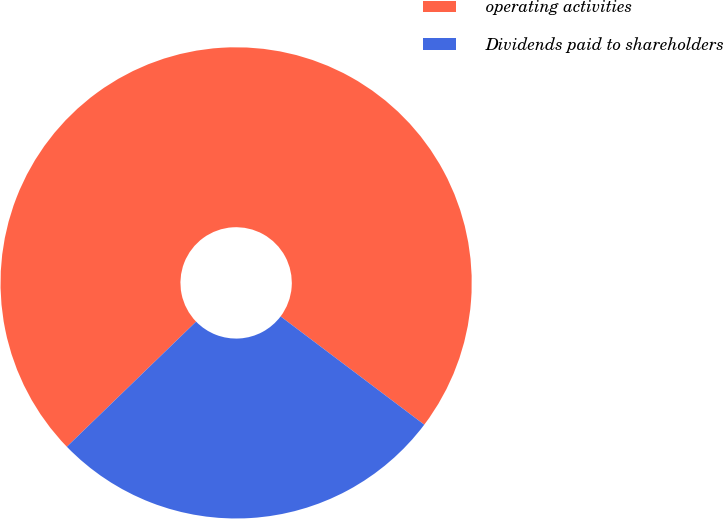Convert chart. <chart><loc_0><loc_0><loc_500><loc_500><pie_chart><fcel>operating activities<fcel>Dividends paid to shareholders<nl><fcel>72.52%<fcel>27.48%<nl></chart> 